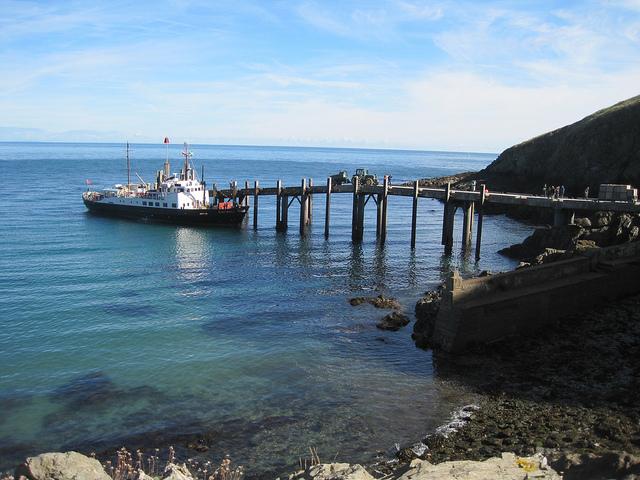How many boats are docked at this pier?
Be succinct. 1. Is there a bridge?
Answer briefly. Yes. Is there any vegetation growing near the shoreline?
Short answer required. Yes. 